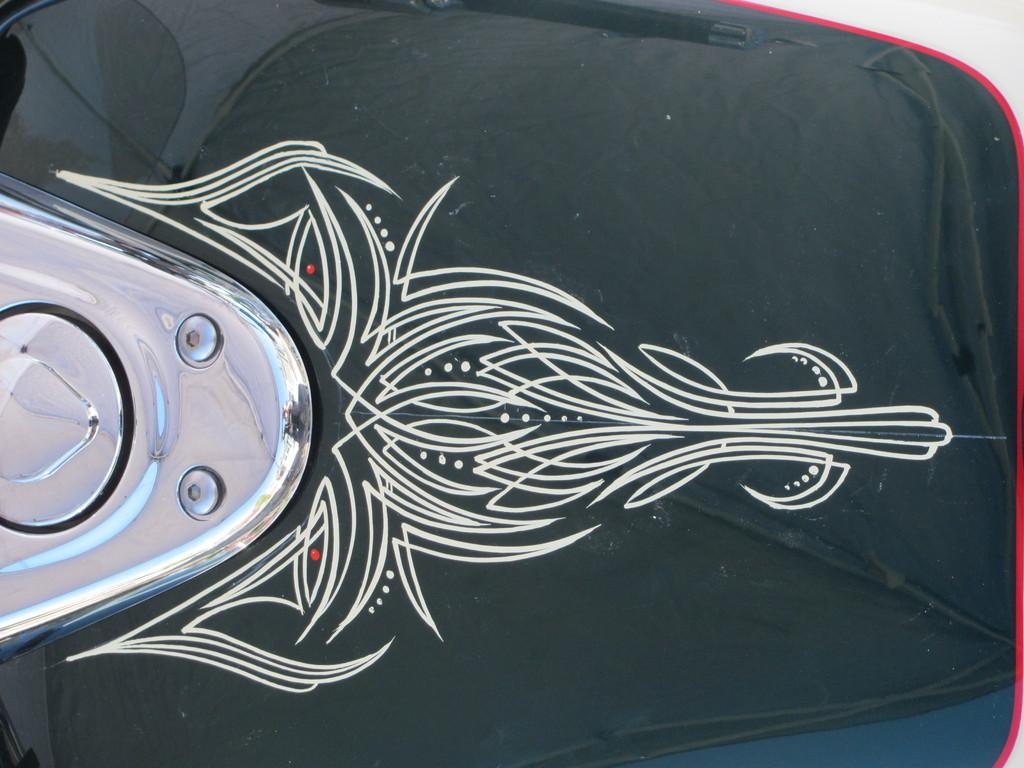What is the main object in the image? There is a fuel tank in the image. To which vehicle does the fuel tank belong? The fuel tank belongs to a vehicle. What design can be seen on the fuel tank? There is a white color design on the fuel tank. What is the background color of the design? The background of the design is black. What type of instrument is being played in the background of the image? There is no instrument being played in the background of the image; it only features a fuel tank with a design. How many beads are visible on the fuel tank in the image? There are no beads visible on the fuel tank in the image; it has a white color design with a black background. 